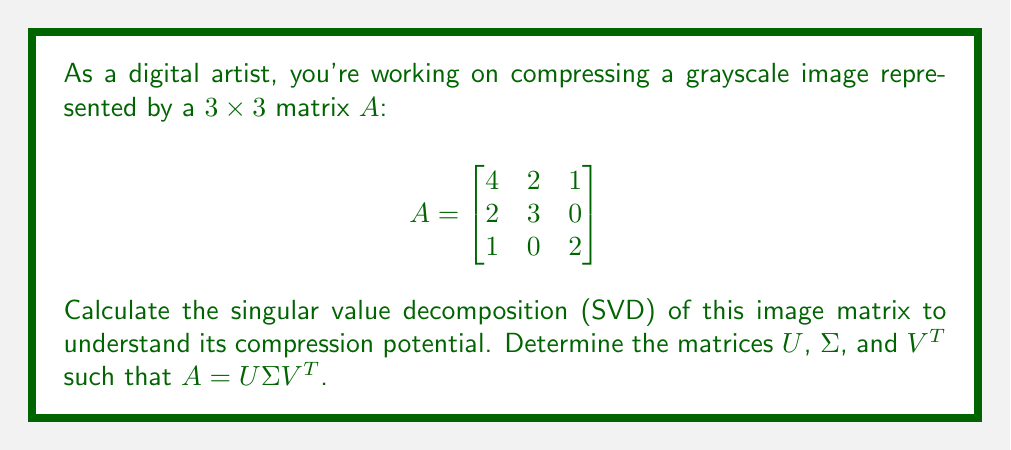Help me with this question. To find the SVD of matrix $A$, we follow these steps:

1) Calculate $A^TA$ and $AA^T$:

   $$A^TA = \begin{bmatrix}
   21 & 14 & 6 \\
   14 & 13 & 2 \\
   6 & 2 & 5
   \end{bmatrix}$$

   $$AA^T = \begin{bmatrix}
   21 & 14 & 6 \\
   14 & 13 & 2 \\
   6 & 2 & 5
   \end{bmatrix}$$

2) Find eigenvalues of $A^TA$ (or $AA^T$):
   Characteristic equation: $\det(A^TA - \lambda I) = 0$
   Solving this, we get: $\lambda_1 \approx 32.5735$, $\lambda_2 \approx 5.5744$, $\lambda_3 \approx 0.8521$

3) The singular values are the square roots of these eigenvalues:
   $\sigma_1 \approx 5.7074$, $\sigma_2 \approx 2.3609$, $\sigma_3 \approx 0.9231$

4) Find eigenvectors of $A^TA$ to get columns of $V$:
   For $\lambda_1$: $v_1 \approx [0.7814, 0.5631, 0.2670]^T$
   For $\lambda_2$: $v_2 \approx [-0.3476, 0.7951, -0.4975]^T$
   For $\lambda_3$: $v_3 \approx [0.5192, -0.2240, -0.8247]^T$

5) Find eigenvectors of $AA^T$ to get columns of $U$:
   For $\lambda_1$: $u_1 \approx [0.7814, 0.5631, 0.2670]^T$
   For $\lambda_2$: $u_2 \approx [-0.3476, 0.7951, -0.4975]^T$
   For $\lambda_3$: $u_3 \approx [0.5192, -0.2240, -0.8247]^T$

6) Construct matrices $U$, $\Sigma$, and $V^T$:

   $$U \approx \begin{bmatrix}
   0.7814 & -0.3476 & 0.5192 \\
   0.5631 & 0.7951 & -0.2240 \\
   0.2670 & -0.4975 & -0.8247
   \end{bmatrix}$$

   $$\Sigma \approx \begin{bmatrix}
   5.7074 & 0 & 0 \\
   0 & 2.3609 & 0 \\
   0 & 0 & 0.9231
   \end{bmatrix}$$

   $$V^T \approx \begin{bmatrix}
   0.7814 & 0.5631 & 0.2670 \\
   -0.3476 & 0.7951 & -0.4975 \\
   0.5192 & -0.2240 & -0.8247
   \end{bmatrix}$$
Answer: $A = U\Sigma V^T$, where:
$U \approx [0.7814, -0.3476, 0.5192; 0.5631, 0.7951, -0.2240; 0.2670, -0.4975, -0.8247]$
$\Sigma \approx \text{diag}(5.7074, 2.3609, 0.9231)$
$V^T \approx [0.7814, 0.5631, 0.2670; -0.3476, 0.7951, -0.4975; 0.5192, -0.2240, -0.8247]$ 